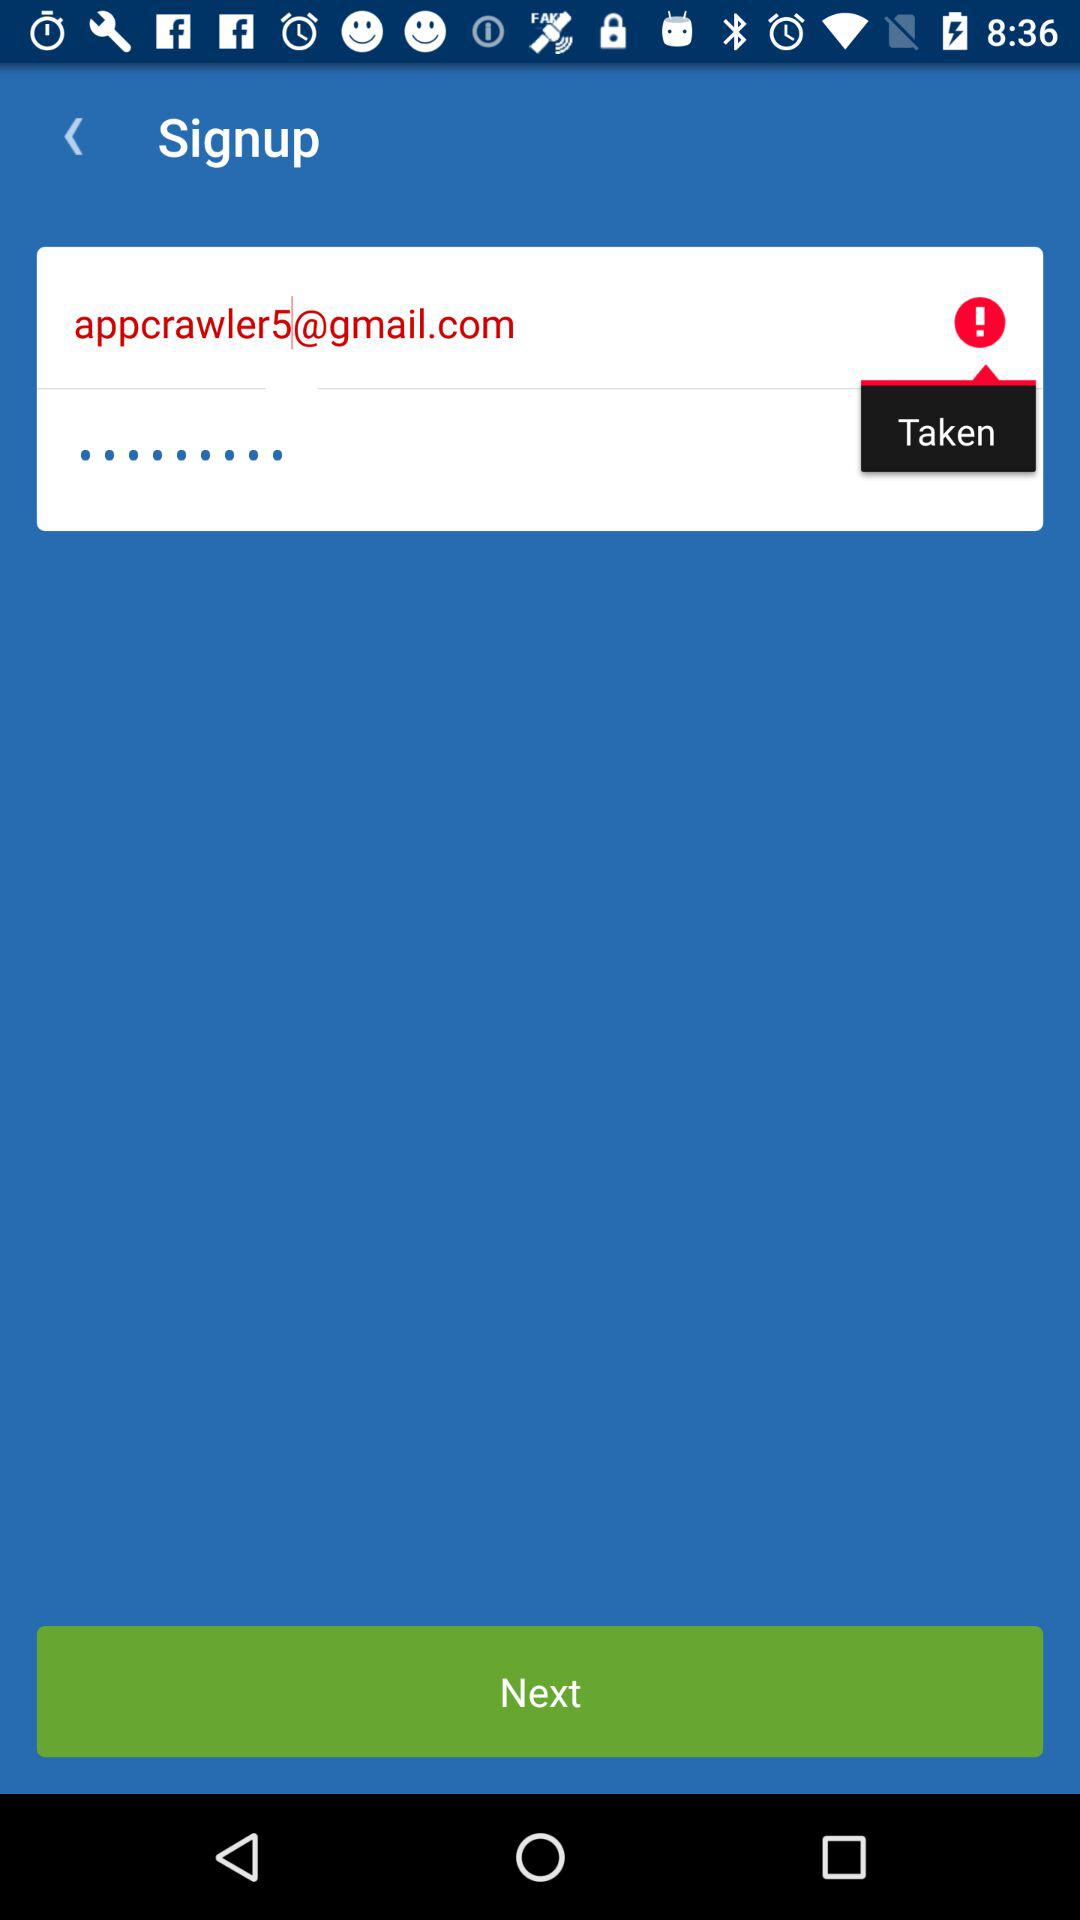How many text inputs have errors?
Answer the question using a single word or phrase. 1 